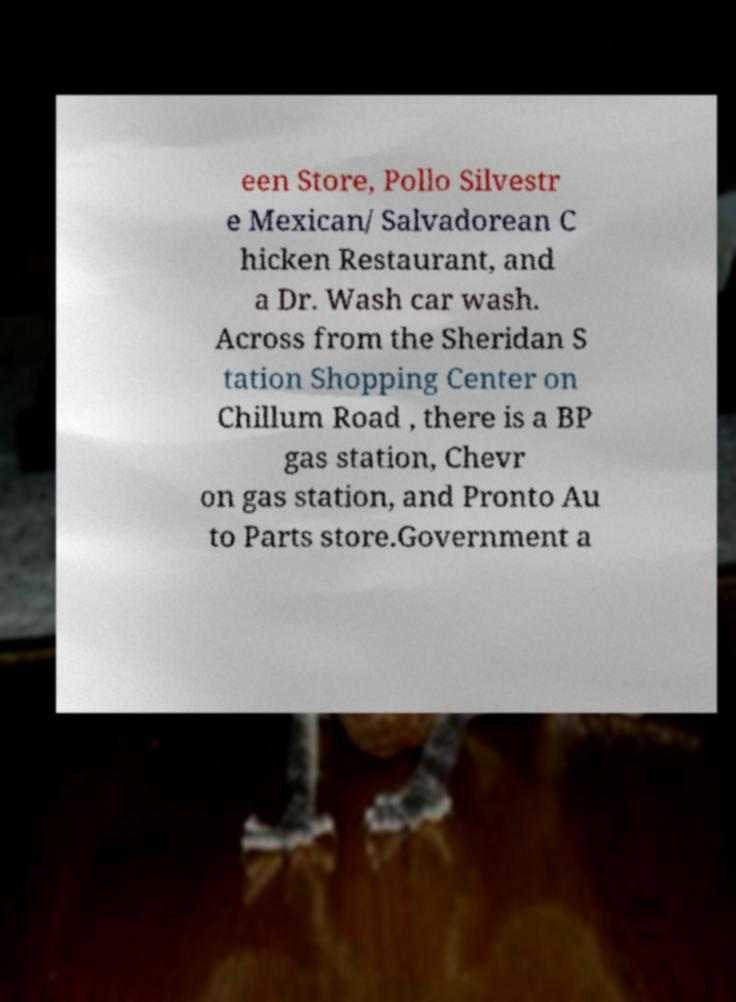Please read and relay the text visible in this image. What does it say? een Store, Pollo Silvestr e Mexican/ Salvadorean C hicken Restaurant, and a Dr. Wash car wash. Across from the Sheridan S tation Shopping Center on Chillum Road , there is a BP gas station, Chevr on gas station, and Pronto Au to Parts store.Government a 